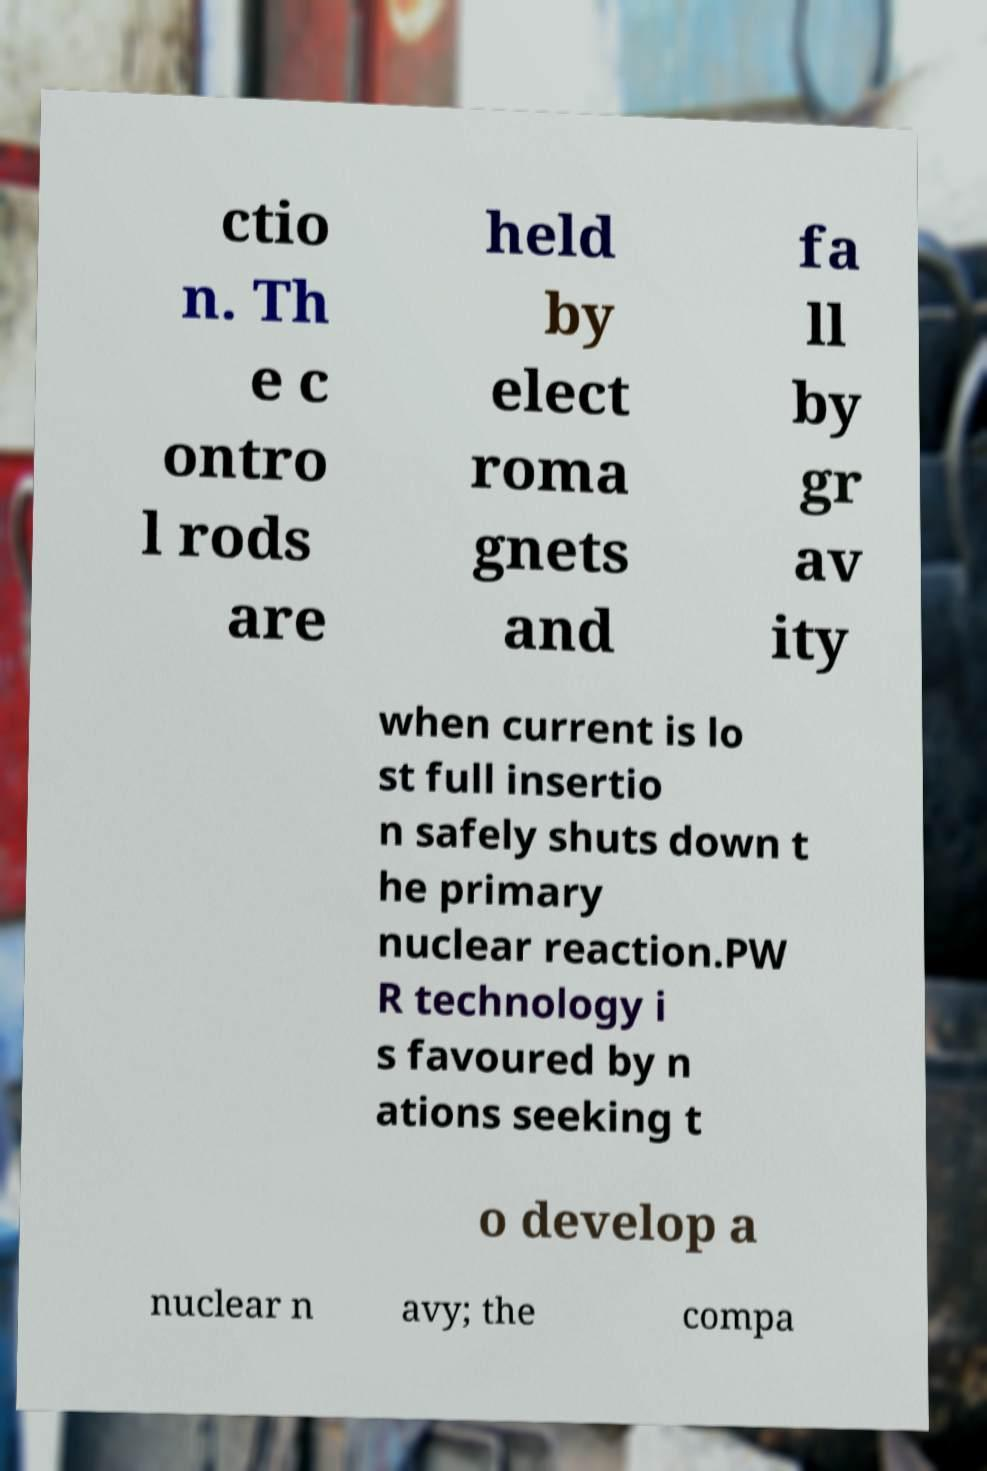I need the written content from this picture converted into text. Can you do that? ctio n. Th e c ontro l rods are held by elect roma gnets and fa ll by gr av ity when current is lo st full insertio n safely shuts down t he primary nuclear reaction.PW R technology i s favoured by n ations seeking t o develop a nuclear n avy; the compa 